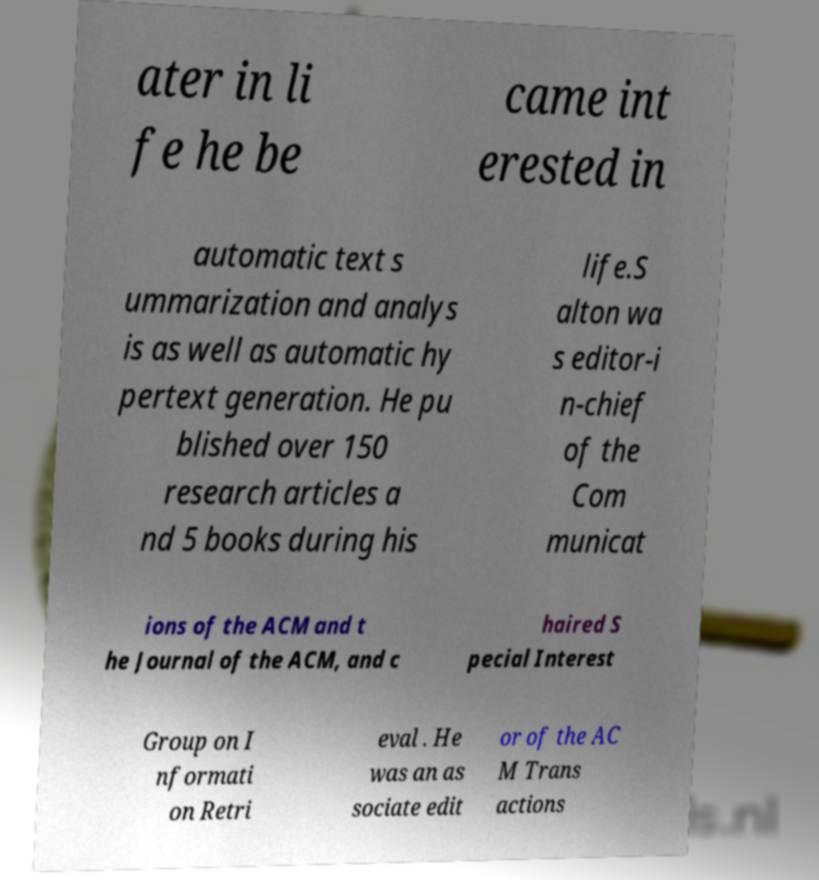What messages or text are displayed in this image? I need them in a readable, typed format. ater in li fe he be came int erested in automatic text s ummarization and analys is as well as automatic hy pertext generation. He pu blished over 150 research articles a nd 5 books during his life.S alton wa s editor-i n-chief of the Com municat ions of the ACM and t he Journal of the ACM, and c haired S pecial Interest Group on I nformati on Retri eval . He was an as sociate edit or of the AC M Trans actions 